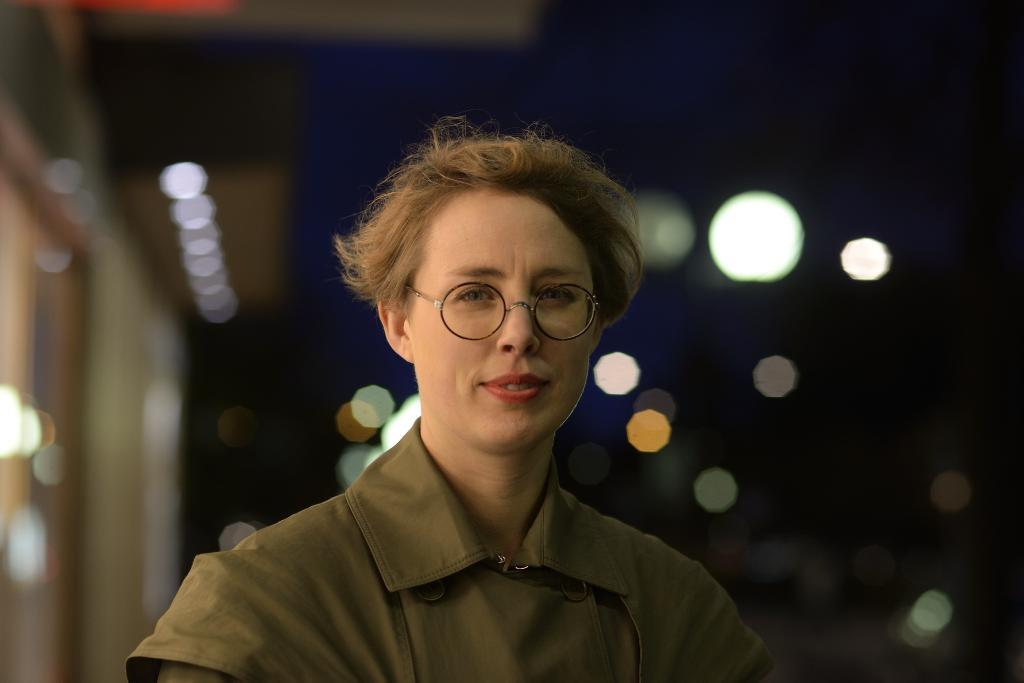Who is the main subject in the image? There is a lady in the center of the image. What can be seen in the background of the image? There are lights in the background of the image. What structure is located to the left side of the image? There is a building to the left side of the image. Reasoning: Let' Let's think step by step in order to produce the conversation. We start by identifying the main subject in the image, which is the lady. Then, we expand the conversation to include other elements in the image, such as the lights in the background and the building to the left side. Each question is designed to elicit a specific detail about the image that is known from the provided facts. Absurd Question/Answer: What type of reward is the lady holding in the image? There is no reward visible in the image; the lady is the main subject, and there are no other objects or items mentioned that could be considered a reward. 